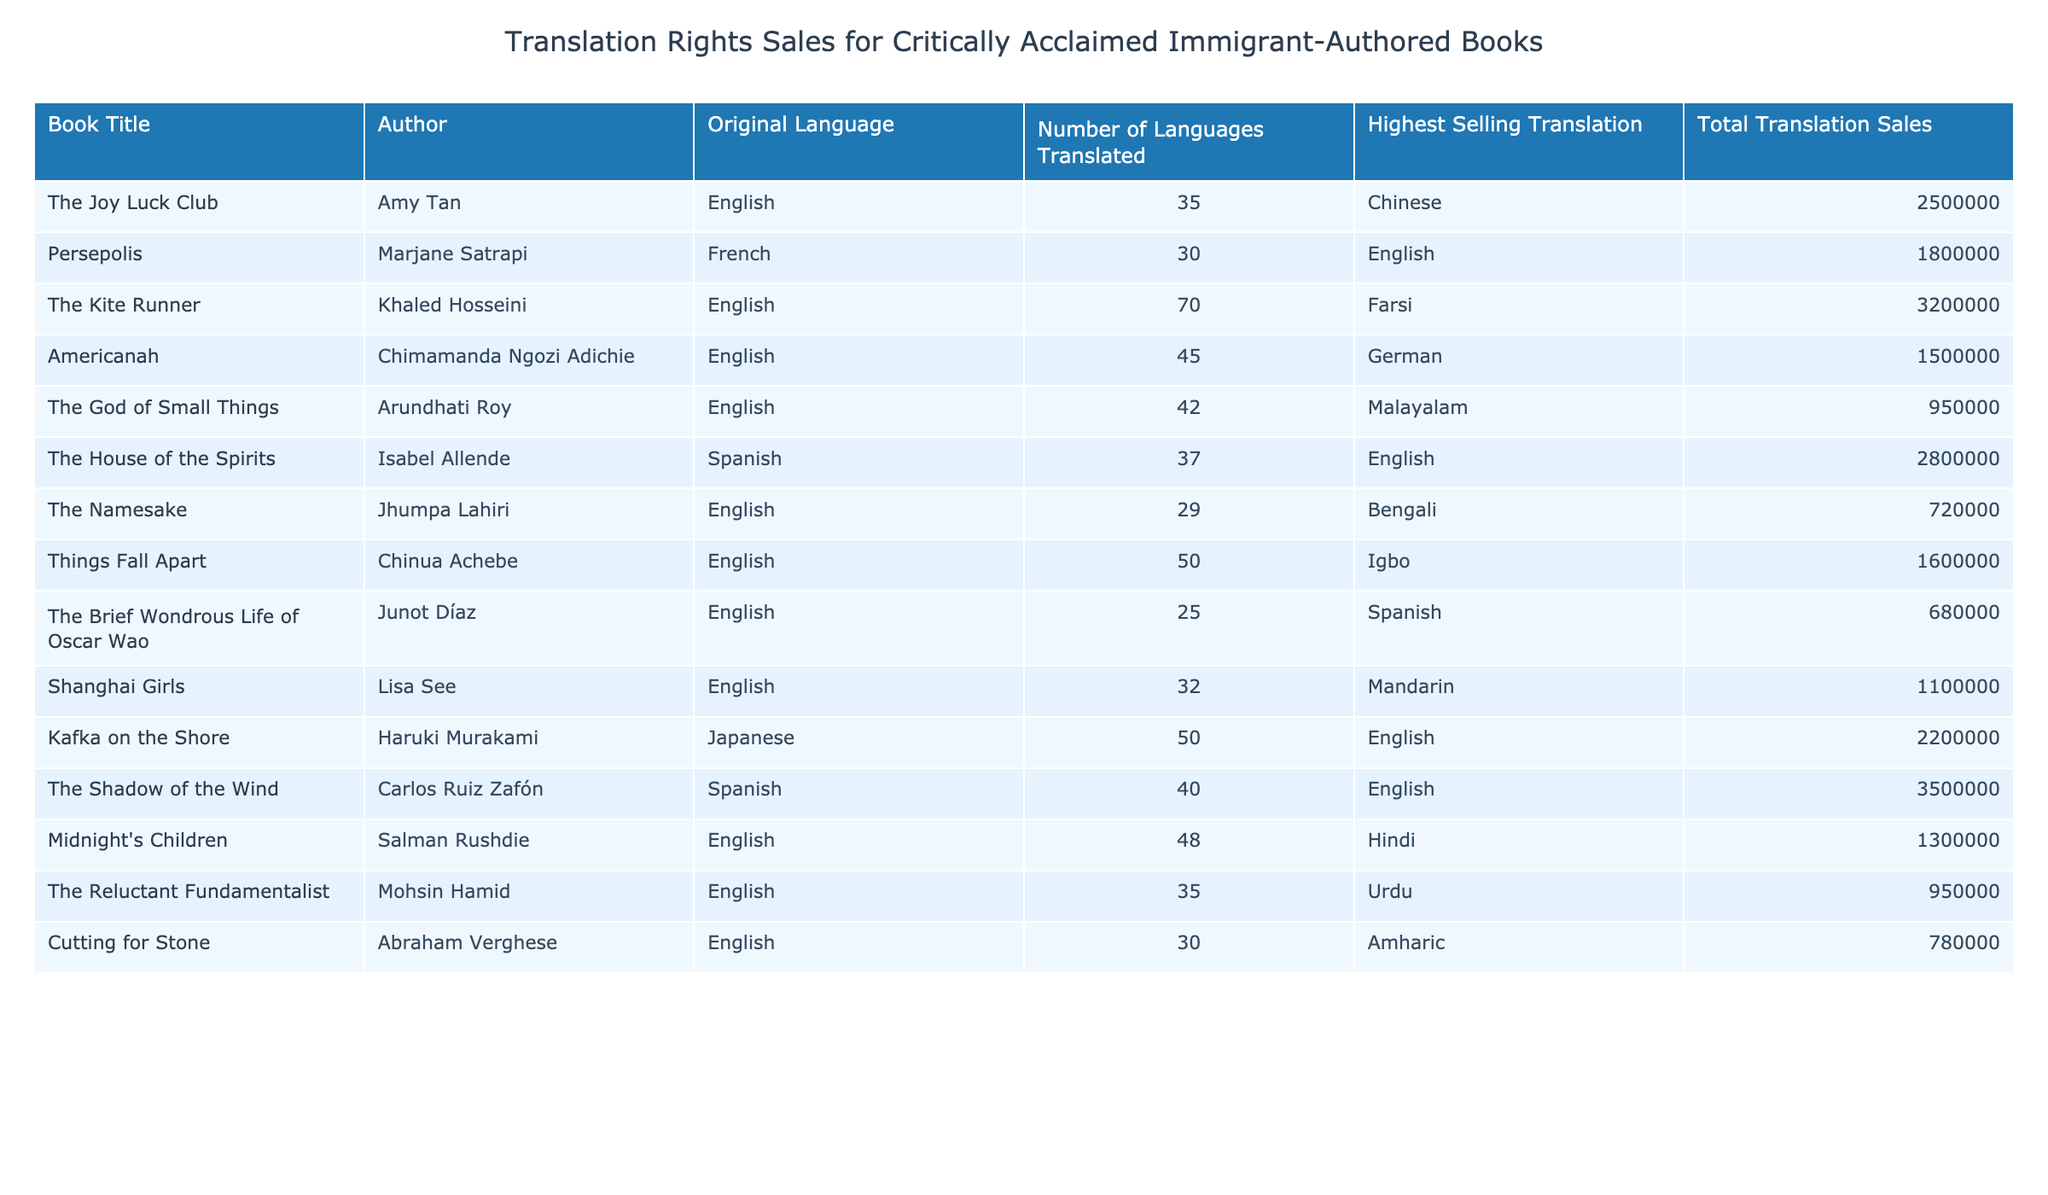What is the highest selling translation among the books listed? By examining the "Highest Selling Translation" column, I can see that "The Shadow of the Wind" has the highest selling translation at 3,500,000.
Answer: 3,500,000 How many languages has "The Kite Runner" been translated into? Looking at the "Number of Languages Translated" column, "The Kite Runner" has been translated into 70 languages.
Answer: 70 Which author has the book with the least total translation sales? Observing the "Total Translation Sales" column, "The Namesake" by Jhumpa Lahiri has the least total sales at 720,000.
Answer: 720,000 What is the average number of languages translated for the books in this table? There are 13 books listed. Summing the "Number of Languages Translated" gives  35 + 30 + 70 + 45 + 42 + 37 + 29 + 50 + 25 + 32 + 50 + 48 + 35 + 30 =  435. Dividing by 13 gives an average of approximately 33.46.
Answer: Approximately 33.46 Is "Americanah" the book with the highest number of languages translated? Checking the "Number of Languages Translated" for "Americanah", which is 45, I note that "The Kite Runner" has 70. Therefore, "Americanah" does not have the highest.
Answer: No How many books were translated into at least 40 languages? By counting the entries in the "Number of Languages Translated" column that are 40 or more, I find 6 books: "The Joy Luck Club", "The Kite Runner", "The House of the Spirits", "Things Fall Apart", "Midnight's Children", and "Americanah".
Answer: 6 What is the total translation sales for books written by authors who wrote in Spanish? Evaluating the sales for the authors who wrote in Spanish, I compute the total as 2,800,000 (Isabel Allende) + 3,500,000 (Carlos Ruiz Zafón) + 680,000 (Junot Díaz) = 7,000,000.
Answer: 7,000,000 Which language has the most translated books in this table? I analyze the original languages of the books, noticing English appears most frequently (11 out of 13 books).
Answer: English 